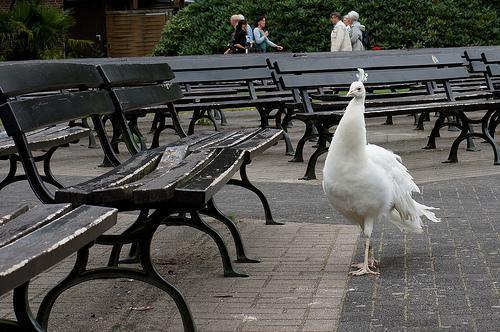How many birds are there?
Give a very brief answer. 1. 